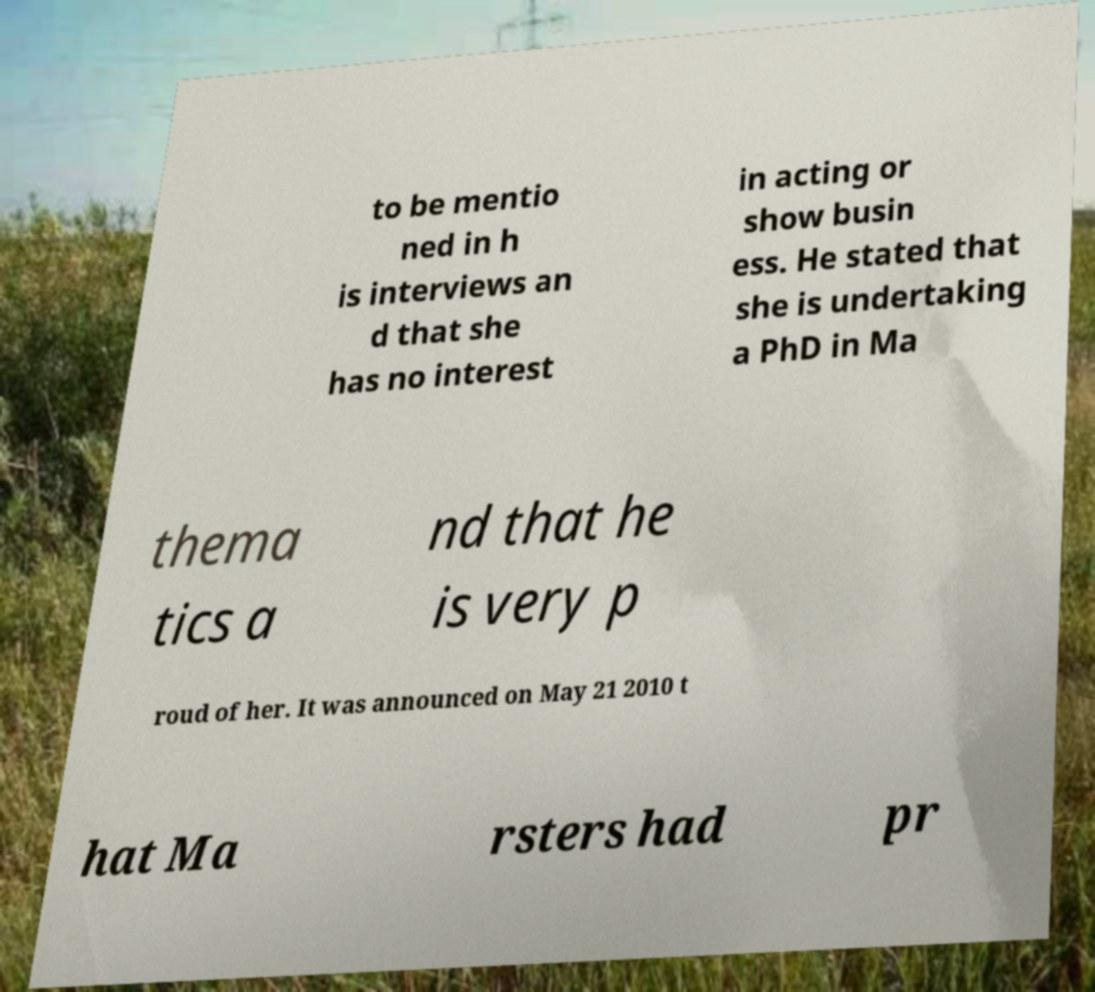I need the written content from this picture converted into text. Can you do that? to be mentio ned in h is interviews an d that she has no interest in acting or show busin ess. He stated that she is undertaking a PhD in Ma thema tics a nd that he is very p roud of her. It was announced on May 21 2010 t hat Ma rsters had pr 